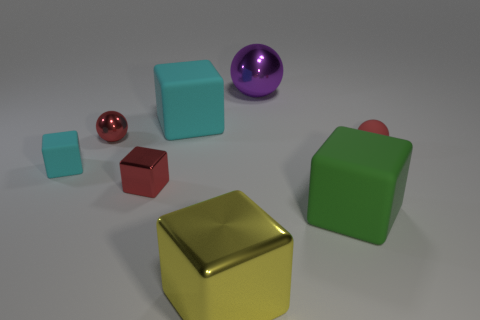Subtract all tiny red cubes. How many cubes are left? 4 Subtract all red spheres. How many spheres are left? 1 Subtract all blocks. How many objects are left? 3 Add 2 tiny cyan cubes. How many objects exist? 10 Subtract 0 yellow balls. How many objects are left? 8 Subtract 3 spheres. How many spheres are left? 0 Subtract all cyan cubes. Subtract all blue cylinders. How many cubes are left? 3 Subtract all blue cylinders. How many purple spheres are left? 1 Subtract all cyan rubber things. Subtract all tiny matte balls. How many objects are left? 5 Add 6 cyan cubes. How many cyan cubes are left? 8 